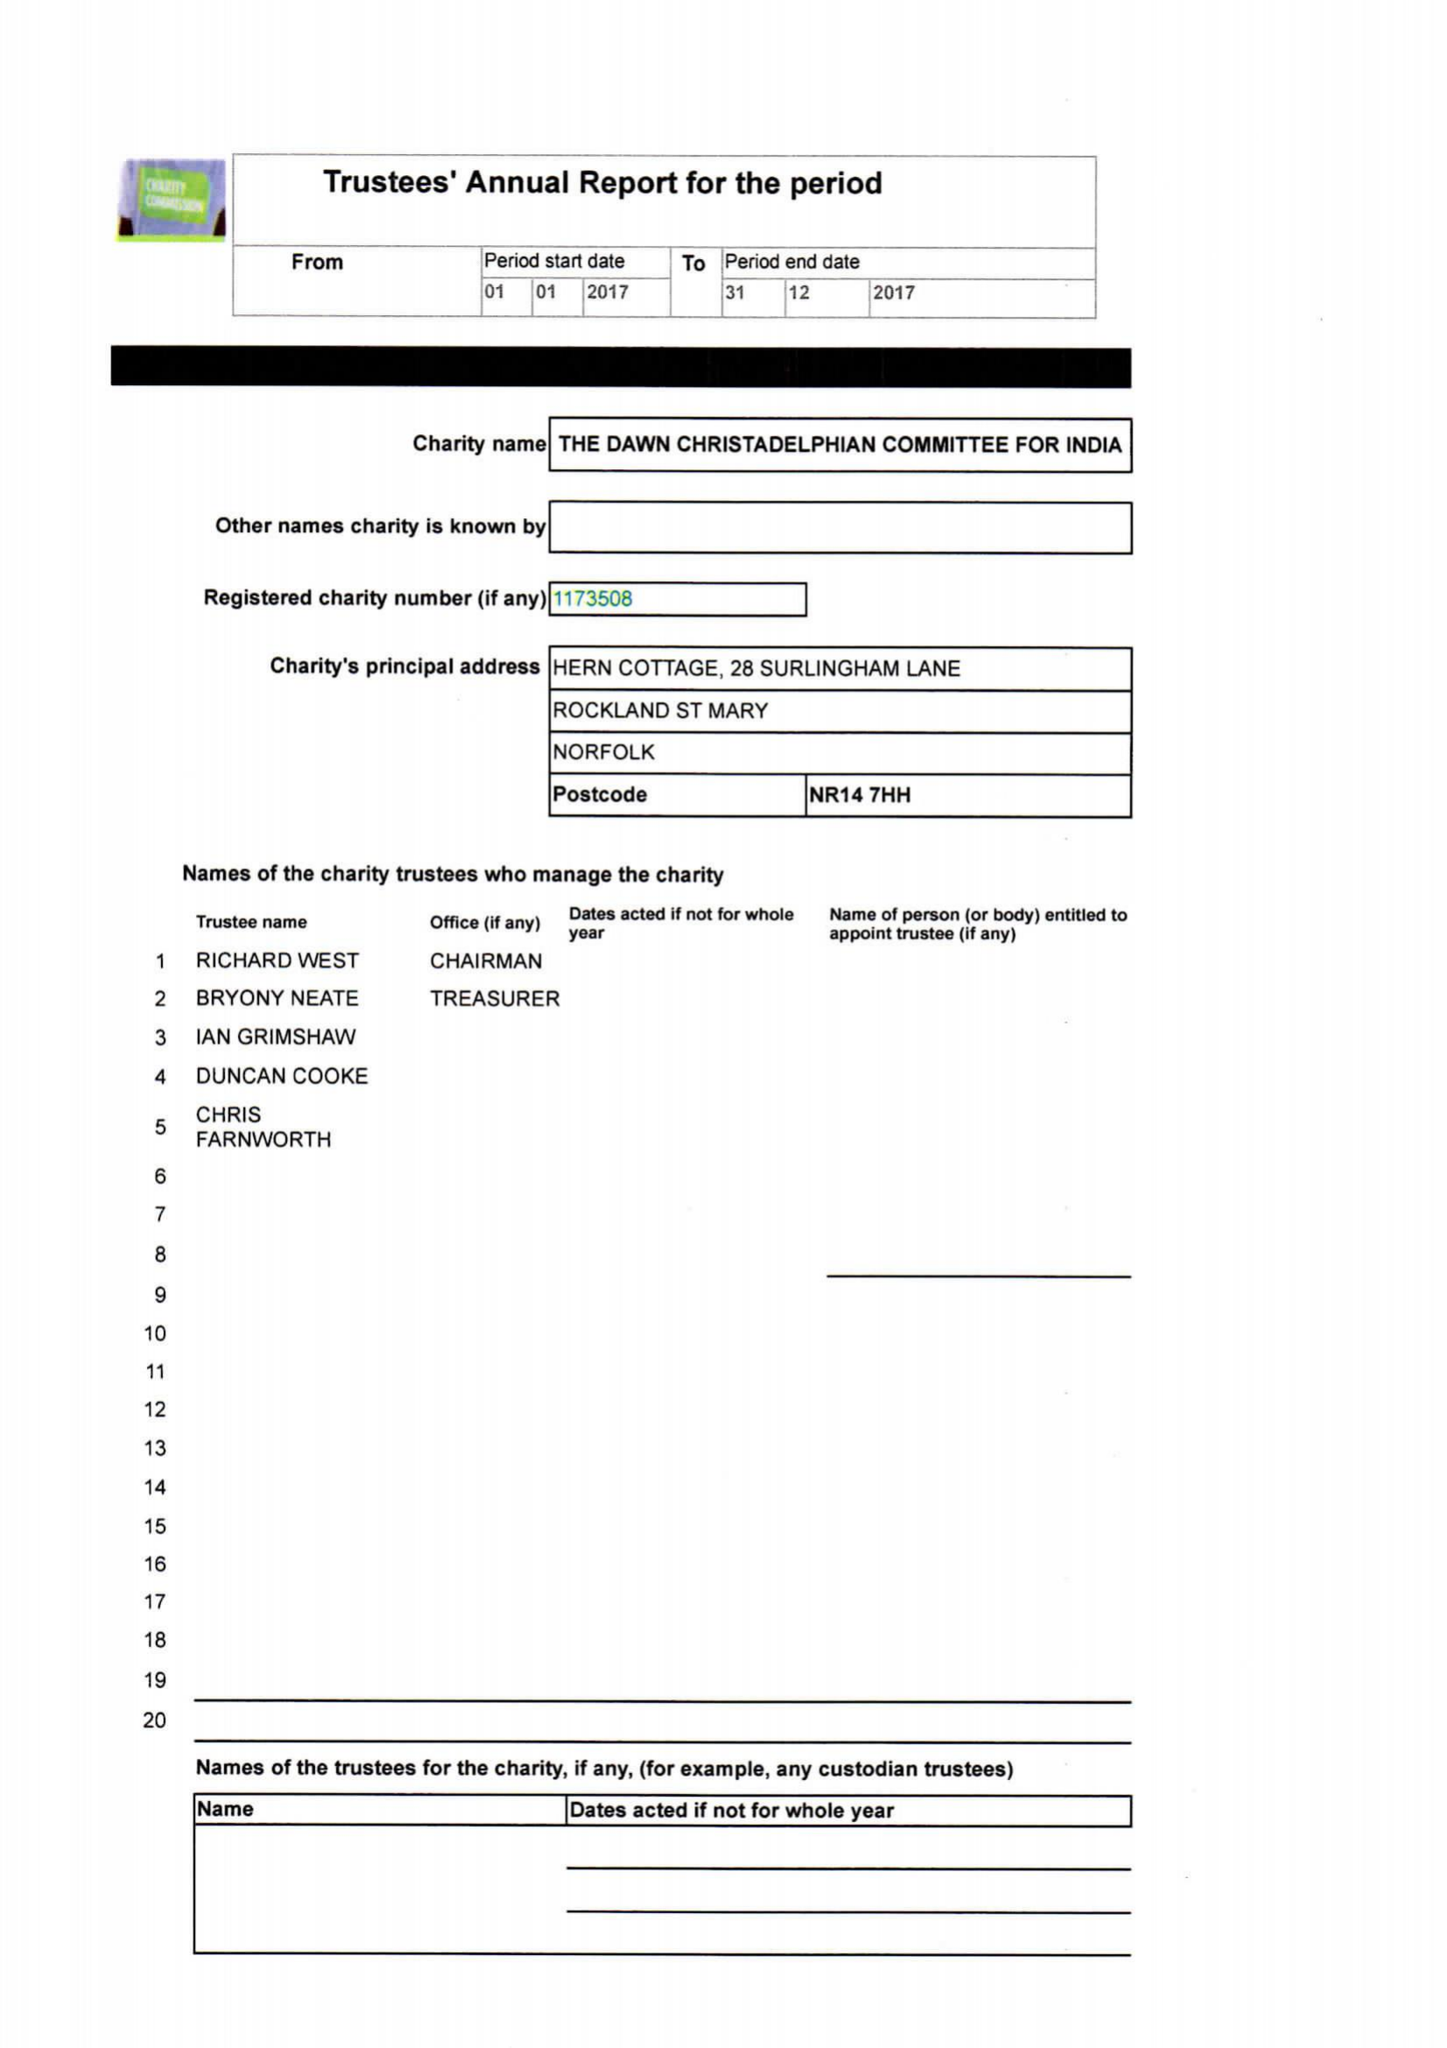What is the value for the charity_number?
Answer the question using a single word or phrase. 1173508 